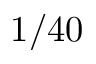<formula> <loc_0><loc_0><loc_500><loc_500>1 / 4 0</formula> 